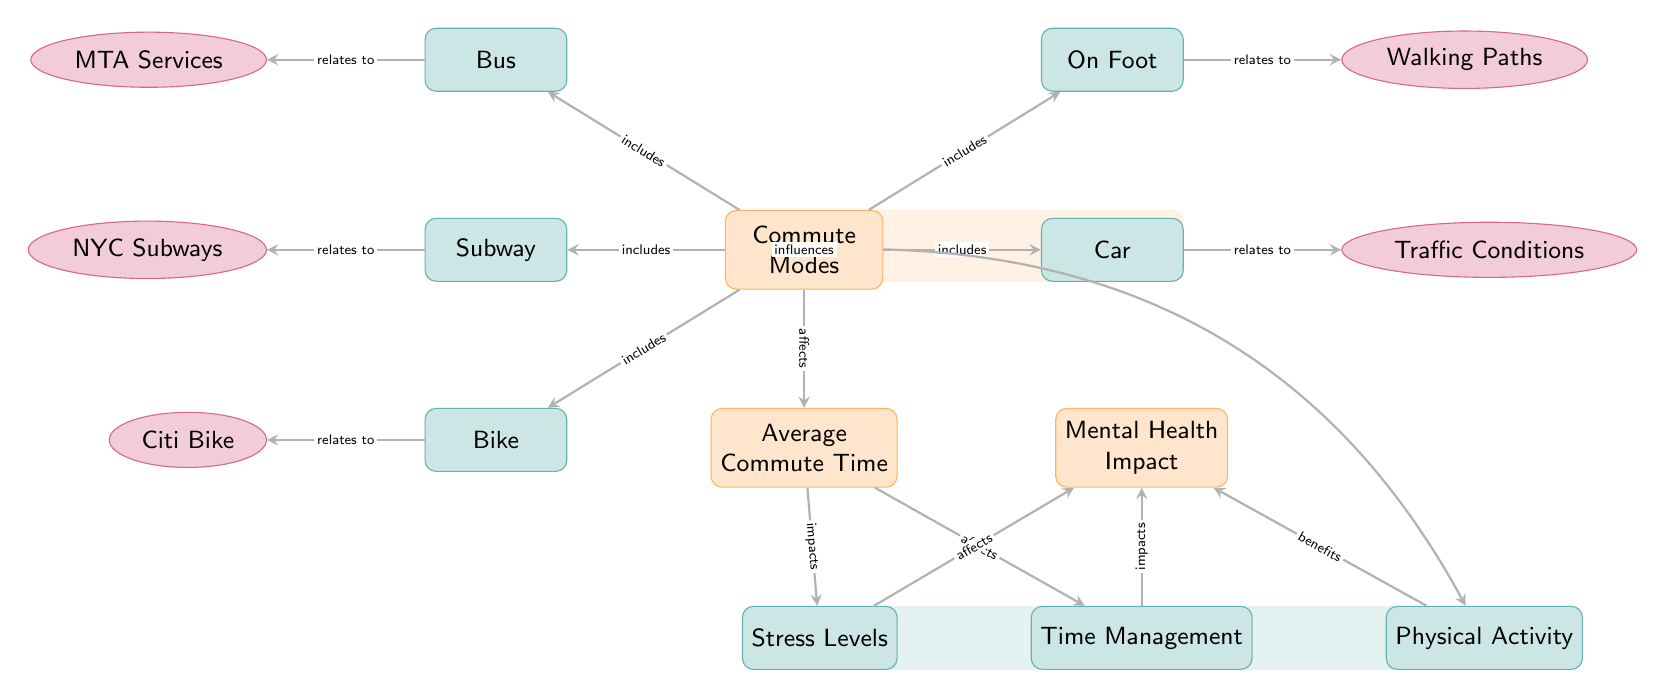What are the five commute modes listed in the diagram? The diagram specifies five commute modes: Subway, Bus, Bike, On Foot, and Car.
Answer: Subway, Bus, Bike, On Foot, Car Which mode of commute relates to NYC Subways? The diagram indicates a relationship where the mode "Subway" directly connects to "NYC Subways," showing this as a specific sub-node under Subway.
Answer: NYC Subways What does the diagram suggest may affect stress levels? Stress levels in the diagram are shown to be influenced by "Average Commute Time," indicating that as commute time changes, so could stress levels.
Answer: Average Commute Time How many mental health impacts are listed in the diagram? There are three impacts on mental health indicated in the diagram: Stress Levels, Time Management, and Physical Activity.
Answer: 3 What is implied about the relationship between physical activity and mental health impact? The diagram illustrates that Physical Activity influences mental health and benefits it, indicating a positive correlation between these two aspects.
Answer: benefits Which commute mode can potentially decrease time management issues? The analysis of the diagram suggests that regardless of the commute mode, any variation in Average Commute Time will affect Time Management, implying that shorter commute modes may enhance time management.
Answer: Average Commute Time What element is mentioned along with bus services in the diagram? The diagram includes "MTA Services" as a specific association with the Bus commute mode, highlighting related transit services.
Answer: MTA Services Which commute mode is related to traffic conditions? According to the diagram, the mode of transport "Car" has a direct link to Traffic Conditions, indicating how car commuters are influenced by traffic issues.
Answer: Traffic Conditions What is the main node that connects commute modes to average commute time? The central node titled "Commute Modes" serves as the primary connection point to "Average Commute Time," linking how different modes influence overall commute duration.
Answer: Commute Modes 